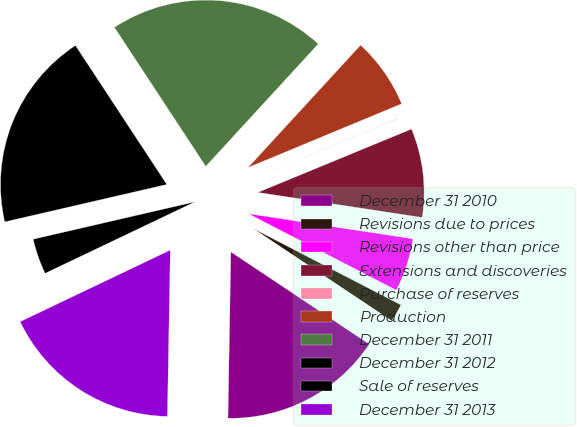Convert chart to OTSL. <chart><loc_0><loc_0><loc_500><loc_500><pie_chart><fcel>December 31 2010<fcel>Revisions due to prices<fcel>Revisions other than price<fcel>Extensions and discoveries<fcel>Purchase of reserves<fcel>Production<fcel>December 31 2011<fcel>December 31 2012<fcel>Sale of reserves<fcel>December 31 2013<nl><fcel>15.92%<fcel>1.76%<fcel>5.19%<fcel>8.63%<fcel>0.04%<fcel>6.91%<fcel>21.08%<fcel>19.36%<fcel>3.47%<fcel>17.64%<nl></chart> 